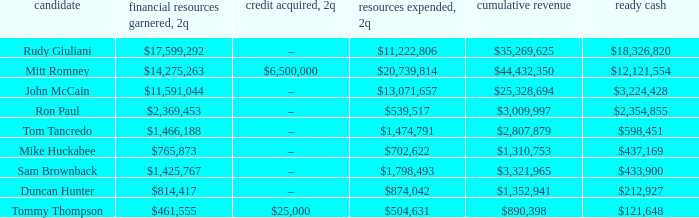How much money was expended for john mccain's campaign in the second quarter? $13,071,657. 